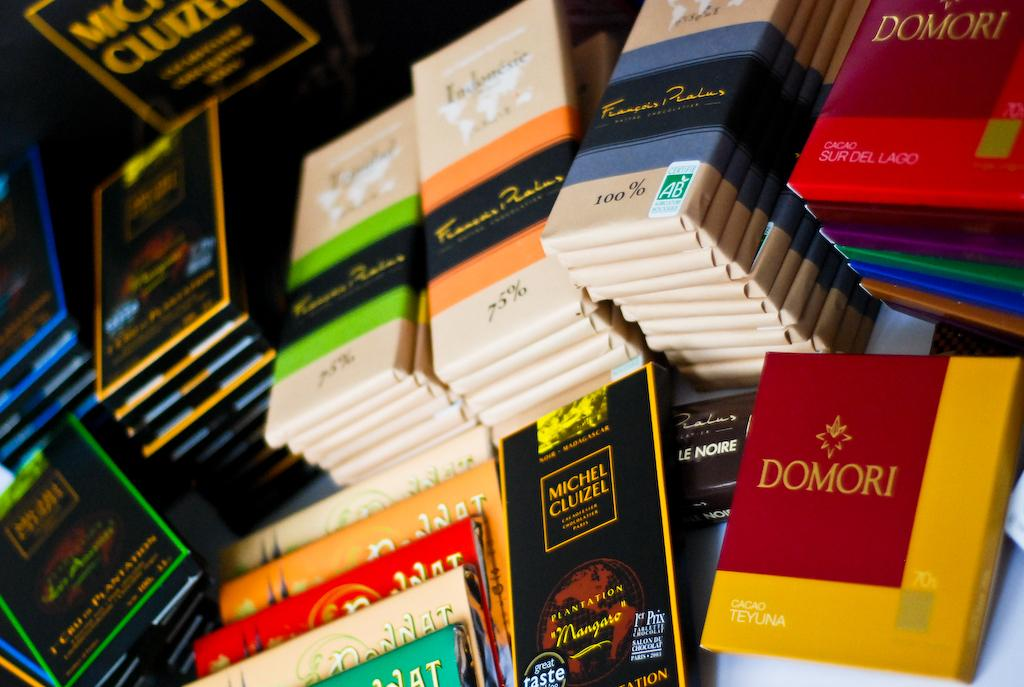<image>
Offer a succinct explanation of the picture presented. a display of a variety of books written by domori 